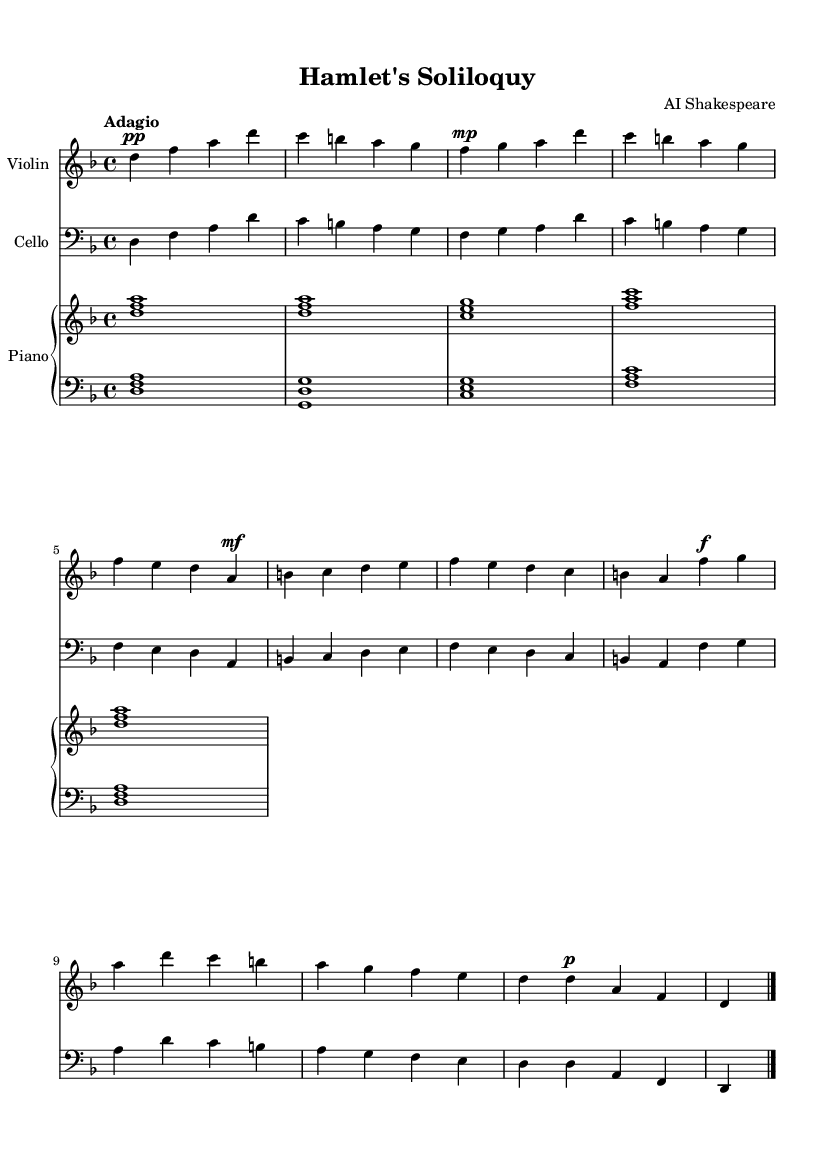What is the key signature of this music? The key signature is D minor, which has one flat (B flat). This can be determined by looking at the key signature indicated at the beginning of the sheet music.
Answer: D minor What is the time signature of this piece? The time signature is four-four, which indicates there are four beats in each measure. This is clearly shown at the start of the sheet music with the notation 4/4.
Answer: Four-four What is the tempo marking for this composition? The tempo marking is Adagio, suggesting a slow and leisurely pace. This is often written at the beginning of the sheet music to guide the performer.
Answer: Adagio How many themes are present in this music? There are two themes present: Theme A and Theme B. Theme A appears multiple times in varied forms, while Theme B is distinct and introduced only once. This can be inferred from the labeled sections of the music.
Answer: Two What dynamics are indicated in the first theme for the violin part? The first theme for the violin indicates a piano dynamic, which means soft, as reflected by the symbol pp right before the first notes of the theme.
Answer: Piano In which voice or instrument does the Coda occur? The Coda appears in the violin part, as it is marked at the end with the notes specifically arranged for the violin, wrapping up the piece.
Answer: Violin 